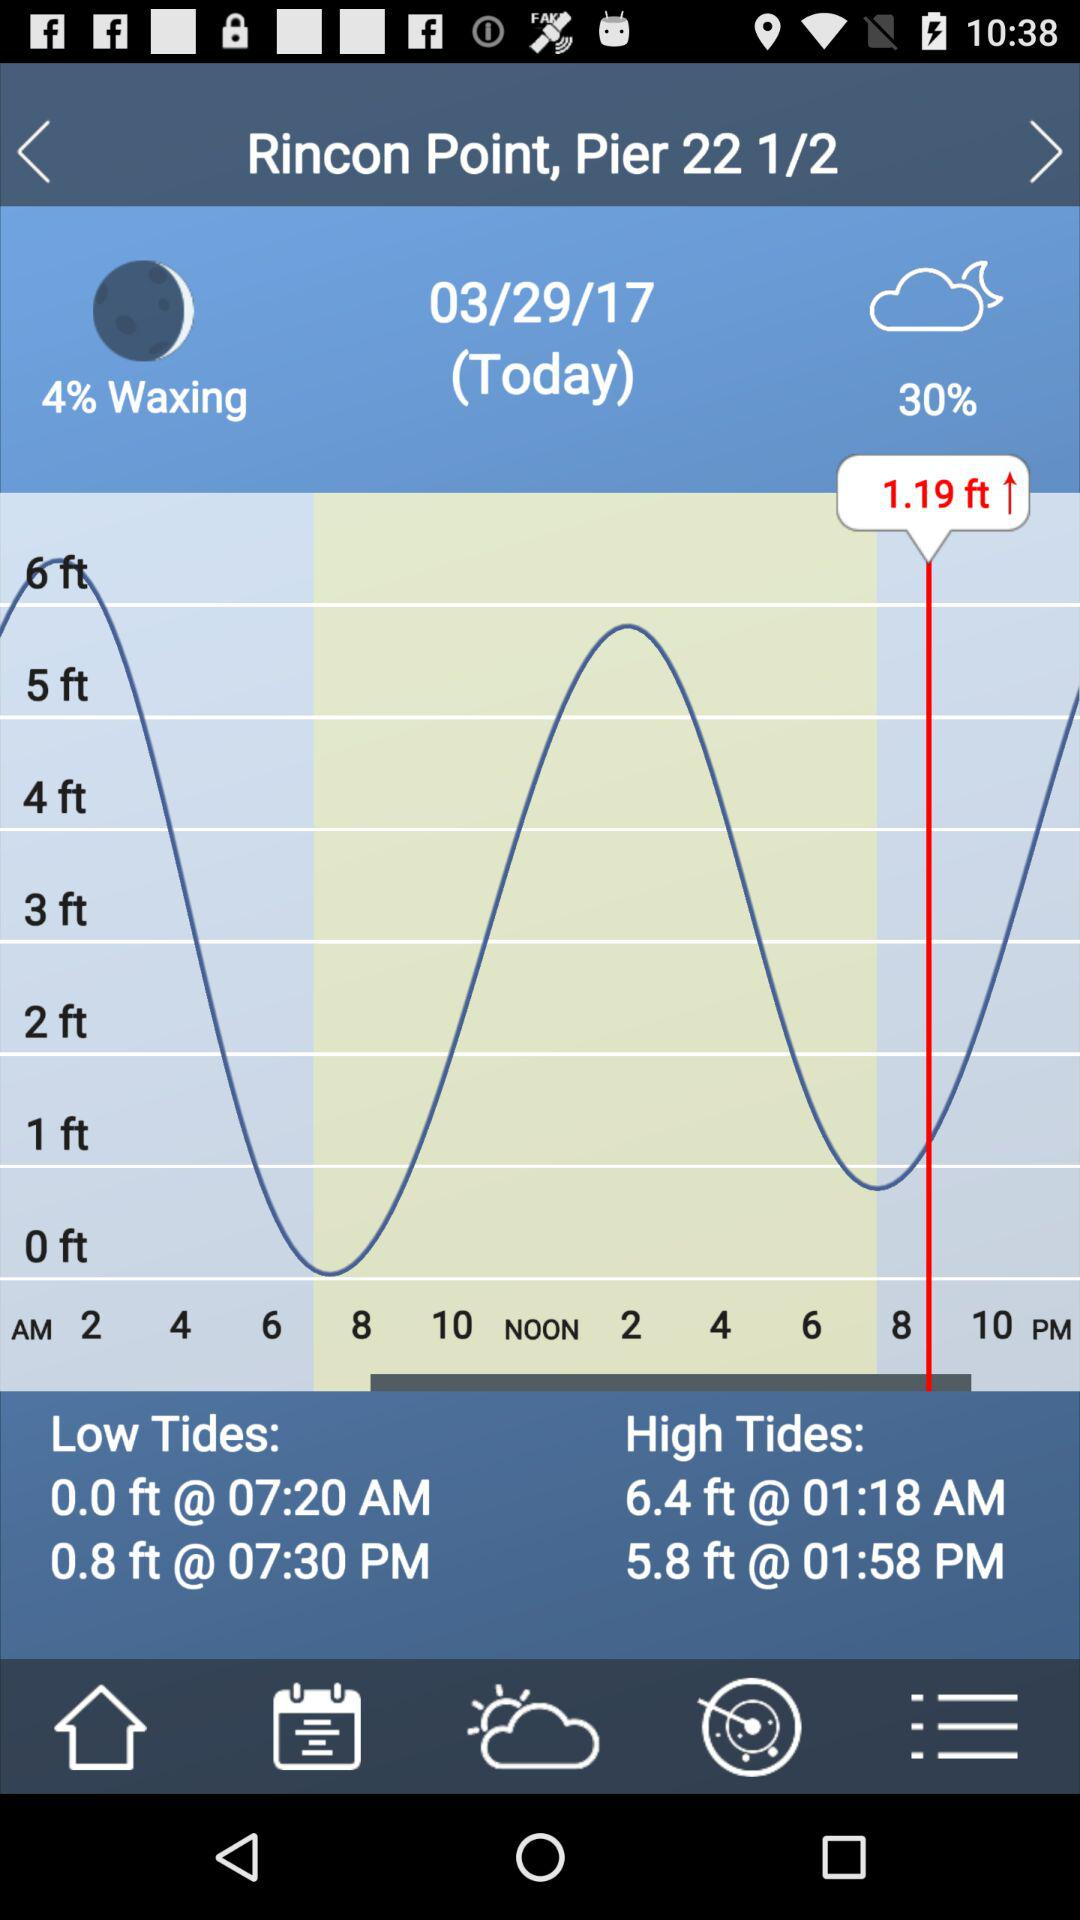What is the weather forecast given on the screen? The weather is cloudy. 